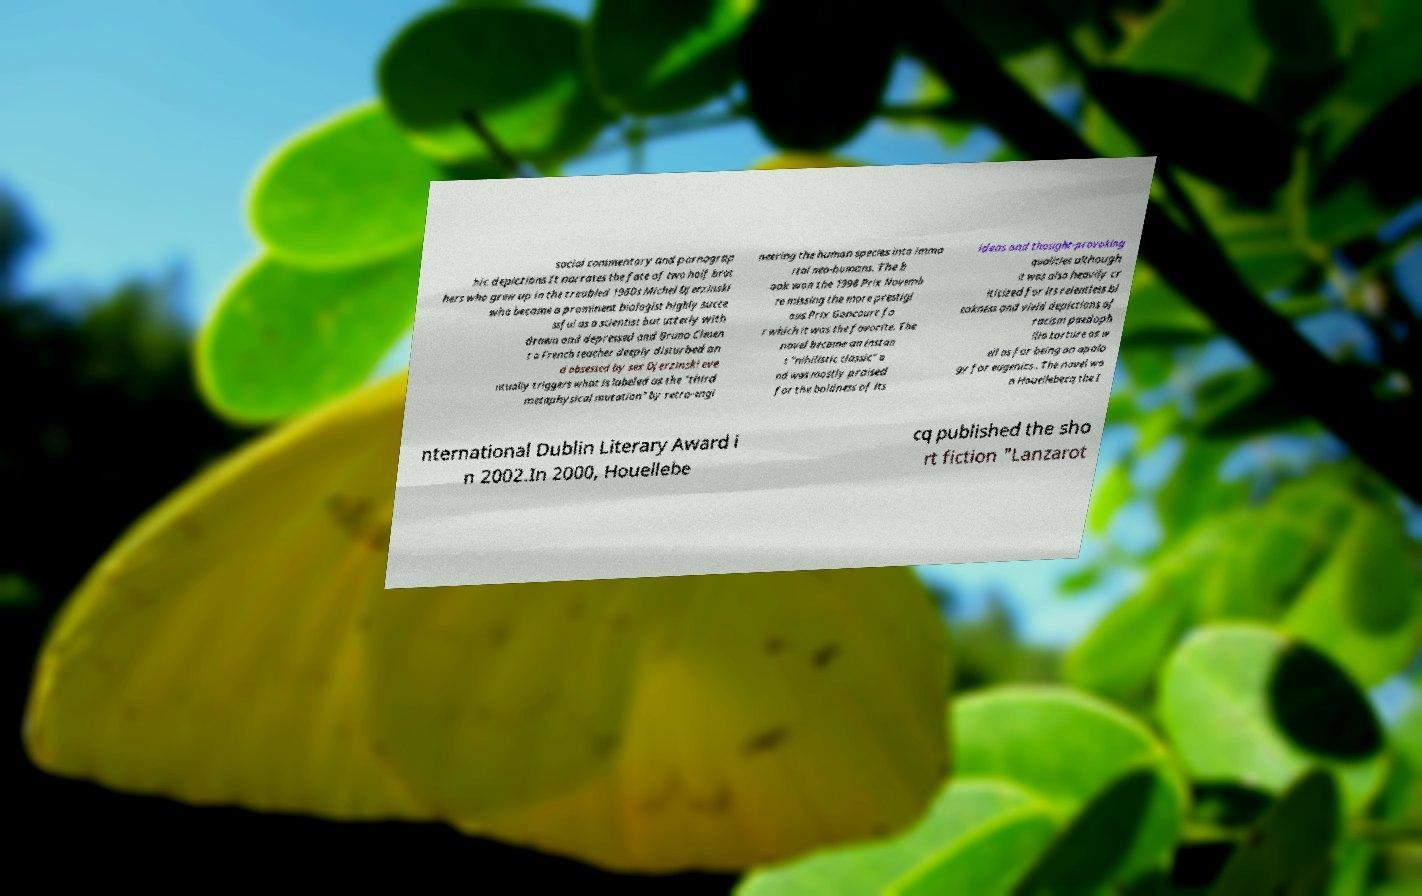Can you read and provide the text displayed in the image?This photo seems to have some interesting text. Can you extract and type it out for me? social commentary and pornograp hic depictions It narrates the fate of two half brot hers who grew up in the troubled 1960s Michel Djerzinski who became a prominent biologist highly succe ssful as a scientist but utterly with drawn and depressed and Bruno Clmen t a French teacher deeply disturbed an d obsessed by sex Djerzinski eve ntually triggers what is labeled as the "third metaphysical mutation" by retro-engi neering the human species into immo rtal neo-humans. The b ook won the 1998 Prix Novemb re missing the more prestigi ous Prix Goncourt fo r which it was the favorite. The novel became an instan t "nihilistic classic" a nd was mostly praised for the boldness of its ideas and thought-provoking qualities although it was also heavily cr iticized for its relentless bl eakness and vivid depictions of racism paedoph ilia torture as w ell as for being an apolo gy for eugenics . The novel wo n Houellebecq the I nternational Dublin Literary Award i n 2002.In 2000, Houellebe cq published the sho rt fiction "Lanzarot 